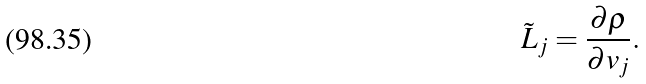<formula> <loc_0><loc_0><loc_500><loc_500>\tilde { L } _ { j } = \frac { \partial \rho } { \partial v _ { j } } .</formula> 